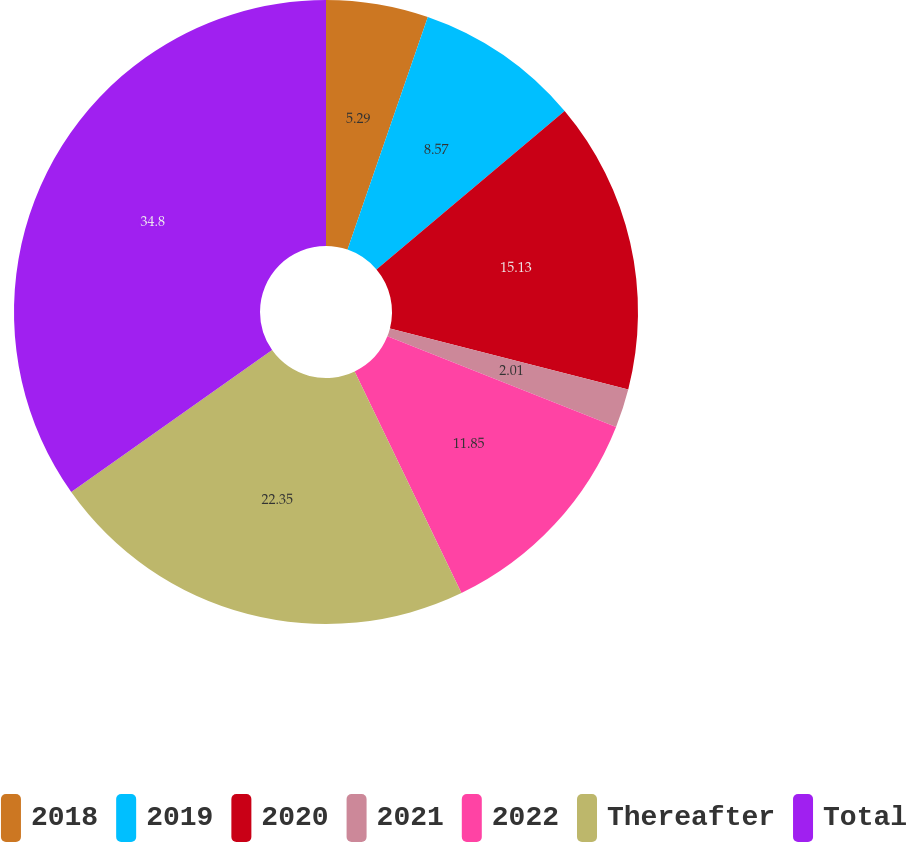Convert chart to OTSL. <chart><loc_0><loc_0><loc_500><loc_500><pie_chart><fcel>2018<fcel>2019<fcel>2020<fcel>2021<fcel>2022<fcel>Thereafter<fcel>Total<nl><fcel>5.29%<fcel>8.57%<fcel>15.13%<fcel>2.01%<fcel>11.85%<fcel>22.35%<fcel>34.79%<nl></chart> 